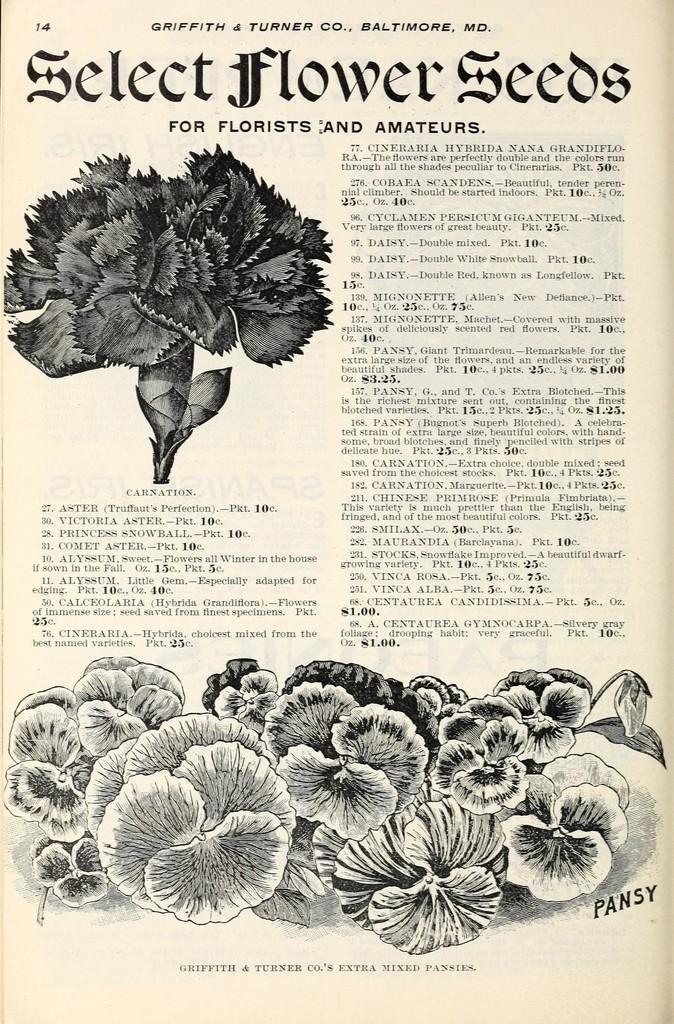How would you summarize this image in a sentence or two? In this image there is a paper, there is text on the paper, there are numbers on the paper, there are flowers on the paper, the background of the image is white in color. 